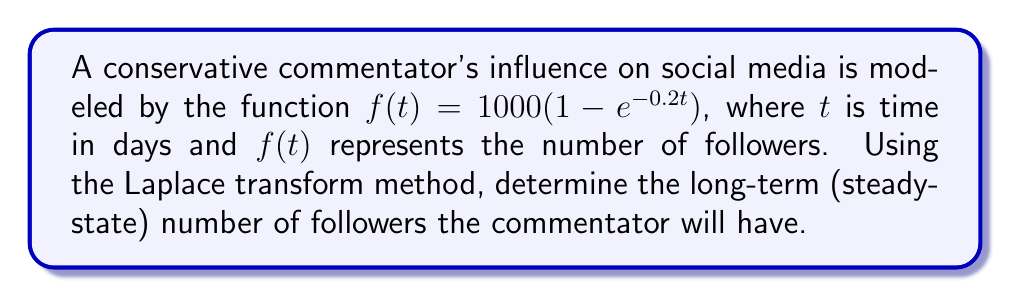Show me your answer to this math problem. To solve this problem using the Laplace transform method, we'll follow these steps:

1) First, let's recall the Laplace transform of $f(t) = 1 - e^{-at}$:

   $\mathcal{L}\{1 - e^{-at}\} = \frac{1}{s} - \frac{1}{s+a}$

2) In our case, $a = 0.2$ and we have a constant factor of 1000. So, the Laplace transform of our function is:

   $F(s) = 1000 \cdot \mathcal{L}\{1 - e^{-0.2t}\} = 1000 \cdot (\frac{1}{s} - \frac{1}{s+0.2})$

3) To find the long-term behavior, we need to use the Final Value Theorem. This theorem states that for a function $f(t)$ with Laplace transform $F(s)$:

   $\lim_{t \to \infty} f(t) = \lim_{s \to 0} sF(s)$

4) Let's apply this to our function:

   $\lim_{t \to \infty} f(t) = \lim_{s \to 0} s \cdot 1000 \cdot (\frac{1}{s} - \frac{1}{s+0.2})$

5) Simplify:

   $= 1000 \cdot \lim_{s \to 0} (1 - \frac{s}{s+0.2})$
   
   $= 1000 \cdot (1 - 0)$
   
   $= 1000$

Therefore, the long-term (steady-state) number of followers the commentator will have is 1000.
Answer: 1000 followers 